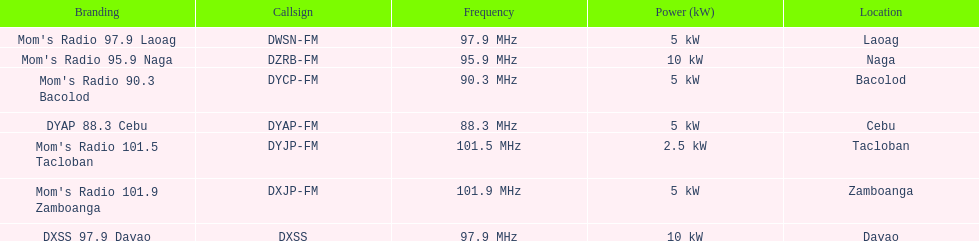What is the difference in kw between naga and bacolod radio? 5 kW. 